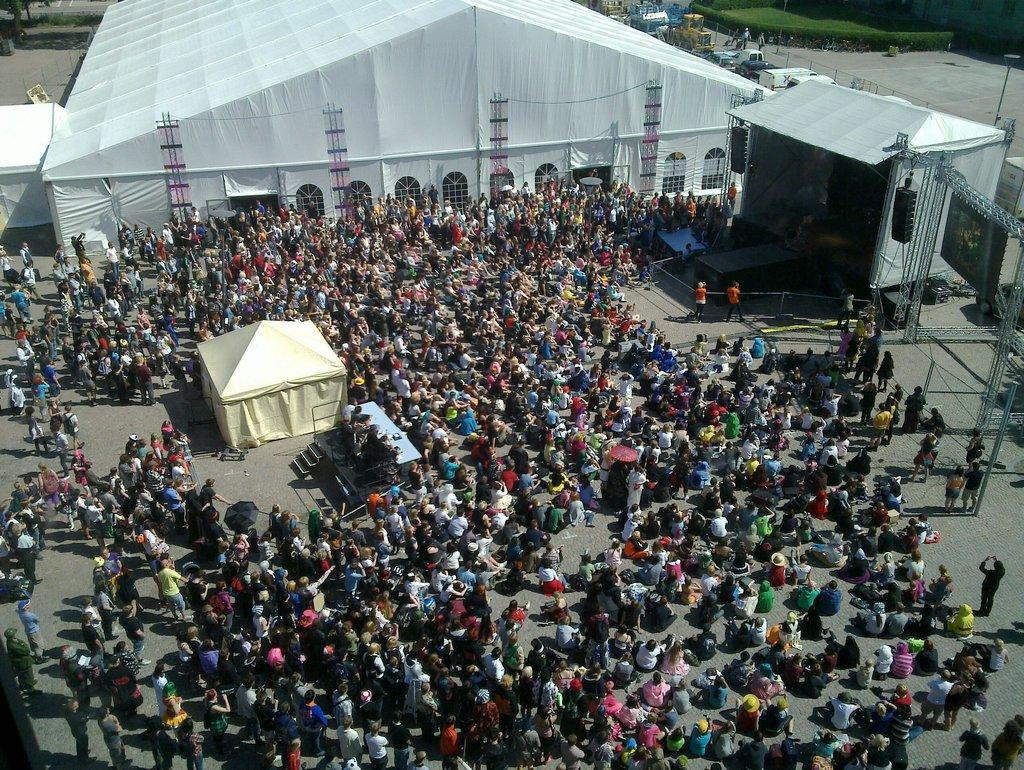What is happening in the image involving people? There is a group of people standing and sitting in the image. What type of natural elements can be seen in the image? There are plants in the image. What man-made objects are present in the image? There are vehicles, tents, a stage, poles, lighting trusses, speakers, and lights in the image. Can you describe any architectural features in the image? There is a staircase in the image. What type of clouds can be seen in the image? There are no clouds visible in the image. What topic are the people in the image discussing? The image does not provide any information about a discussion or topic being discussed by the people. Is there a bike present in the image? There is no bike present in the image. 